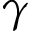<formula> <loc_0><loc_0><loc_500><loc_500>\gamma</formula> 